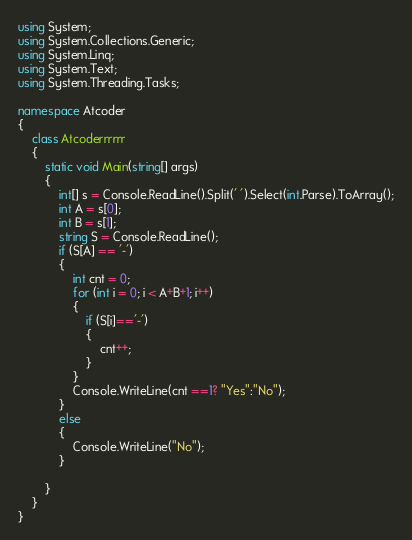<code> <loc_0><loc_0><loc_500><loc_500><_C#_>using System;
using System.Collections.Generic;
using System.Linq;
using System.Text;
using System.Threading.Tasks;

namespace Atcoder
{
    class Atcoderrrrrr
    {
        static void Main(string[] args)
        {
            int[] s = Console.ReadLine().Split(' ').Select(int.Parse).ToArray();
            int A = s[0];
            int B = s[1];
            string S = Console.ReadLine();
            if (S[A] == '-')
            {
                int cnt = 0;
                for (int i = 0; i < A+B+1; i++)
                {
                    if (S[i]=='-')
                    {
                        cnt++;
                    }
                }
                Console.WriteLine(cnt ==1? "Yes":"No");
            }
            else
            {
                Console.WriteLine("No");
            }

        }
    }
}</code> 